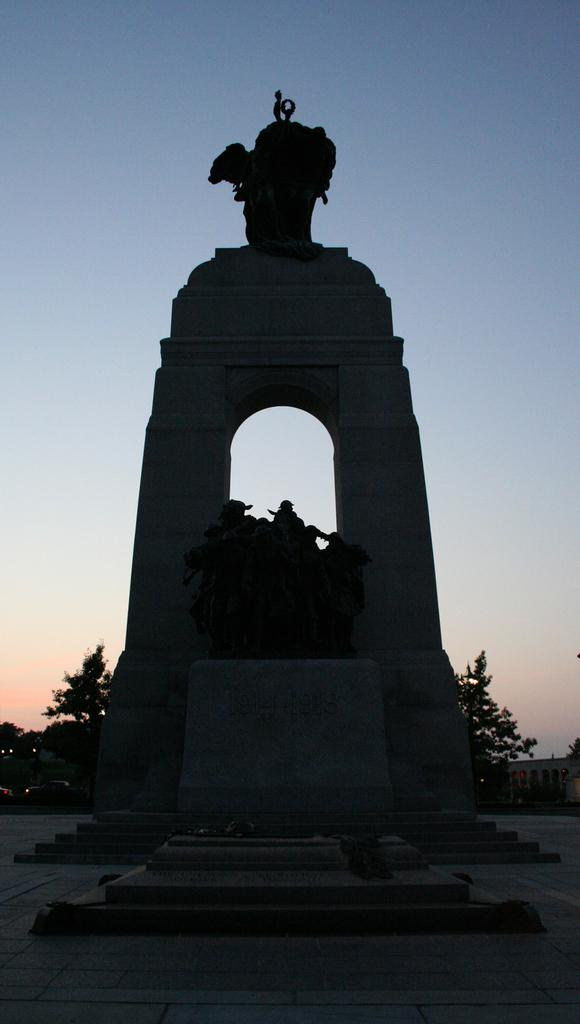What type of surface is visible in the image? There is ground visible in the image. What is the color of the statue in the image? The statue in the image is black colored. What is located behind the statue? There is a concrete structure behind the statue. What can be seen in the background of the image? Trees, a car, a building, and the sky are visible in the background of the image. How many rabbits are playing with a sponge in the image? There are no rabbits or sponge present in the image. What color is the kite flying in the background of the image? There is no kite present in the image; only trees, a car, a building, and the sky are visible in the background. 